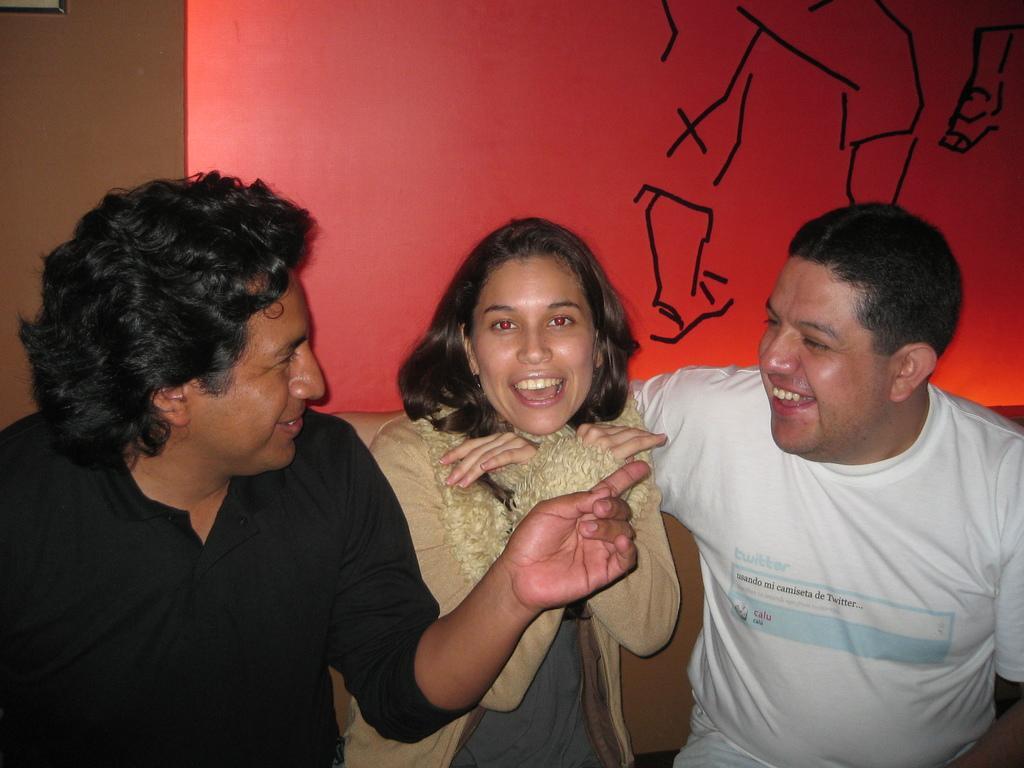Could you give a brief overview of what you see in this image? In the picture I can see two men and a woman are smiling. In the background I can see a red color wall which has a painting of a person. 